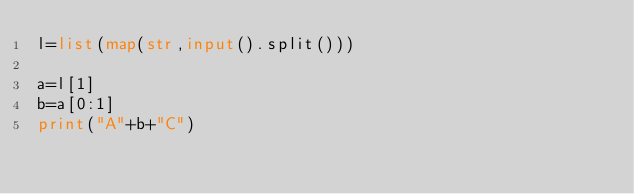<code> <loc_0><loc_0><loc_500><loc_500><_Python_>l=list(map(str,input().split()))

a=l[1]
b=a[0:1]
print("A"+b+"C")</code> 